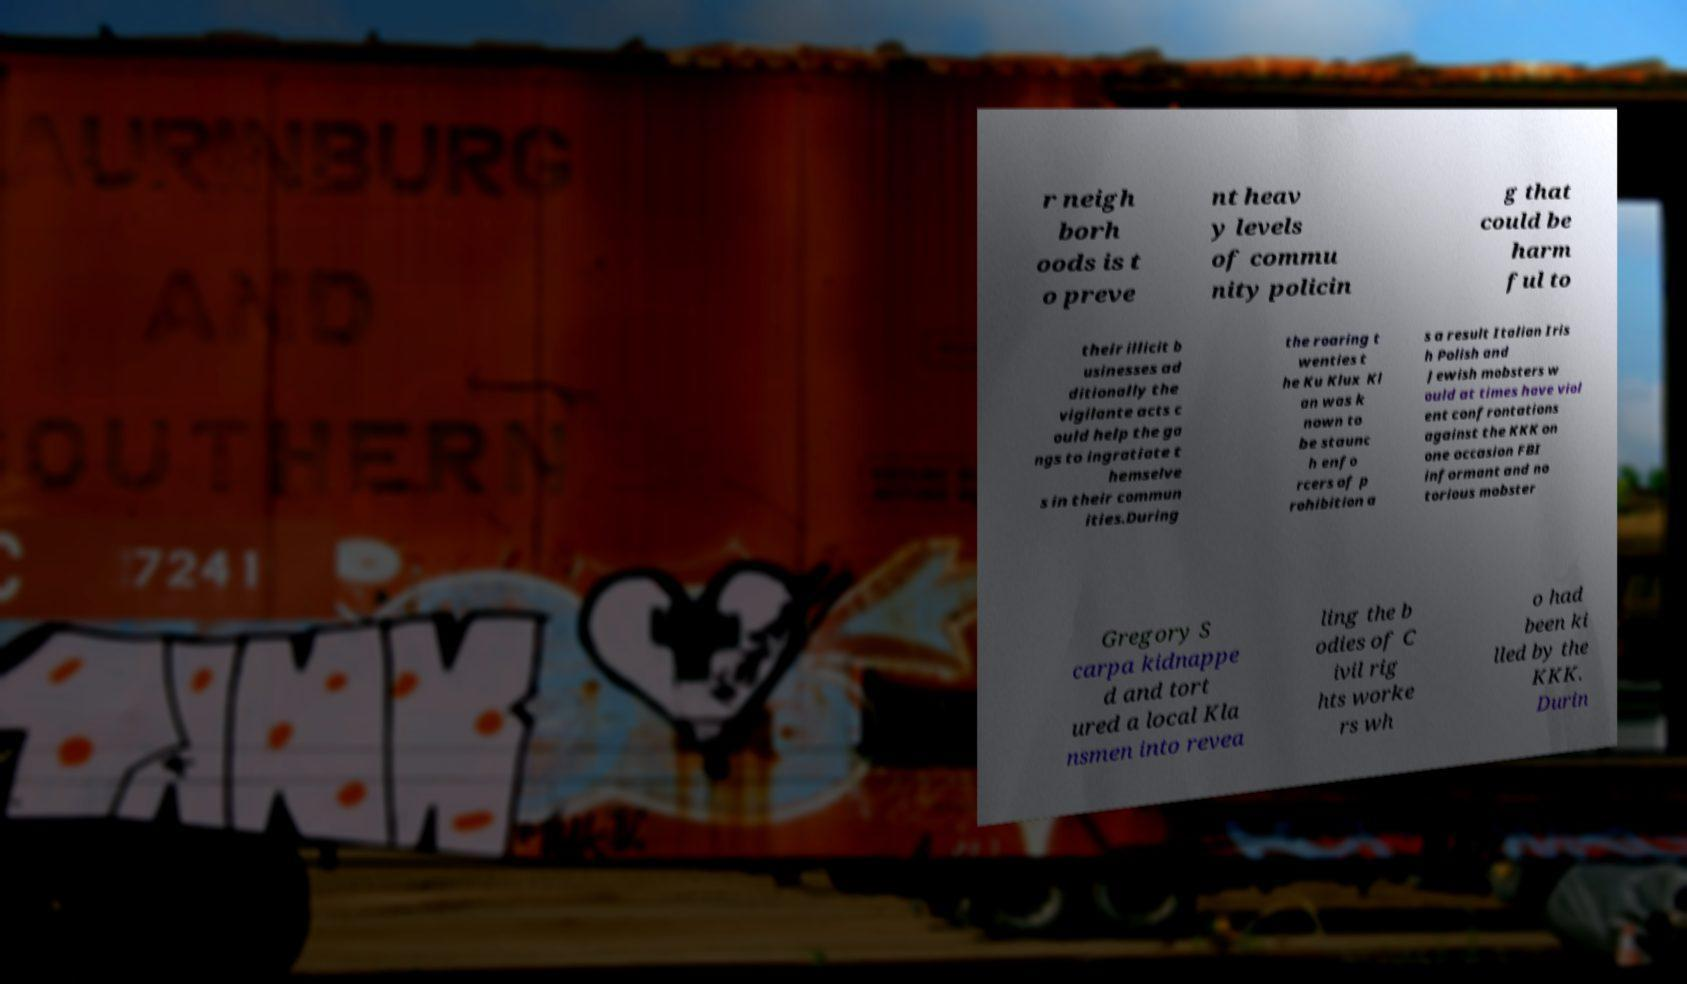What messages or text are displayed in this image? I need them in a readable, typed format. r neigh borh oods is t o preve nt heav y levels of commu nity policin g that could be harm ful to their illicit b usinesses ad ditionally the vigilante acts c ould help the ga ngs to ingratiate t hemselve s in their commun ities.During the roaring t wenties t he Ku Klux Kl an was k nown to be staunc h enfo rcers of p rohibition a s a result Italian Iris h Polish and Jewish mobsters w ould at times have viol ent confrontations against the KKK on one occasion FBI informant and no torious mobster Gregory S carpa kidnappe d and tort ured a local Kla nsmen into revea ling the b odies of C ivil rig hts worke rs wh o had been ki lled by the KKK. Durin 